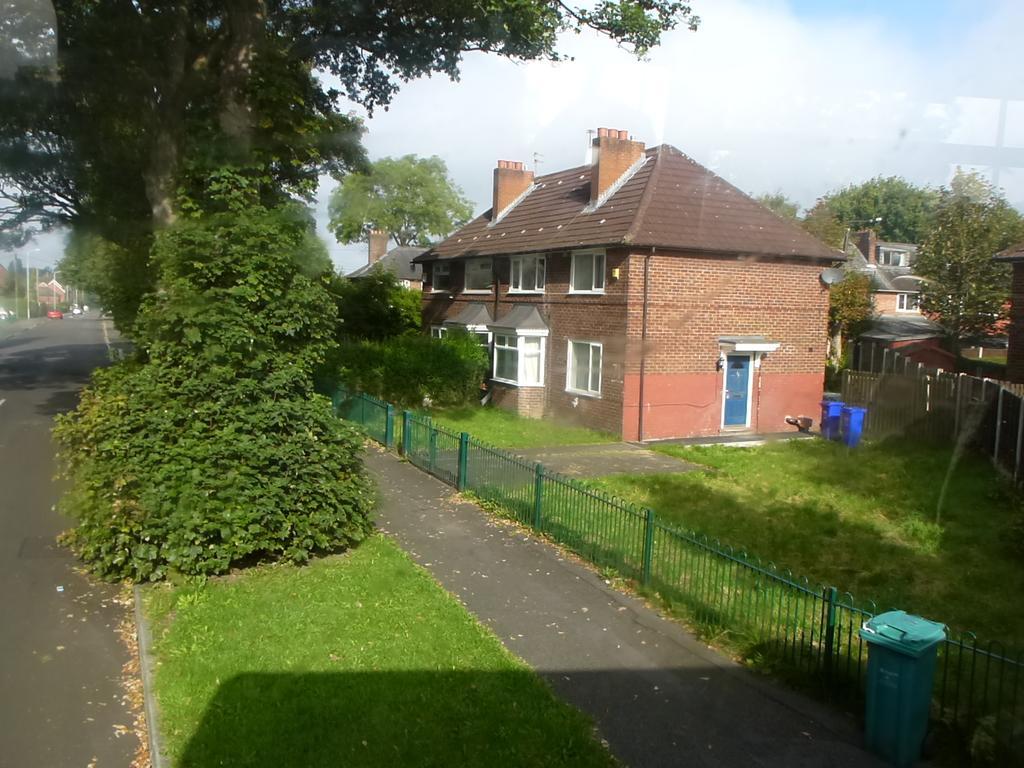How would you summarize this image in a sentence or two? In this image we can see buildings, street poles, street lights, trash bins, fences, bushes, trees and sky with clouds. 